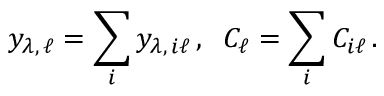<formula> <loc_0><loc_0><loc_500><loc_500>y _ { \lambda , \, \ell } = \sum _ { i } y _ { \lambda , \, i \ell } \, , \, C _ { \ell } = \sum _ { i } C _ { i \ell } \, .</formula> 